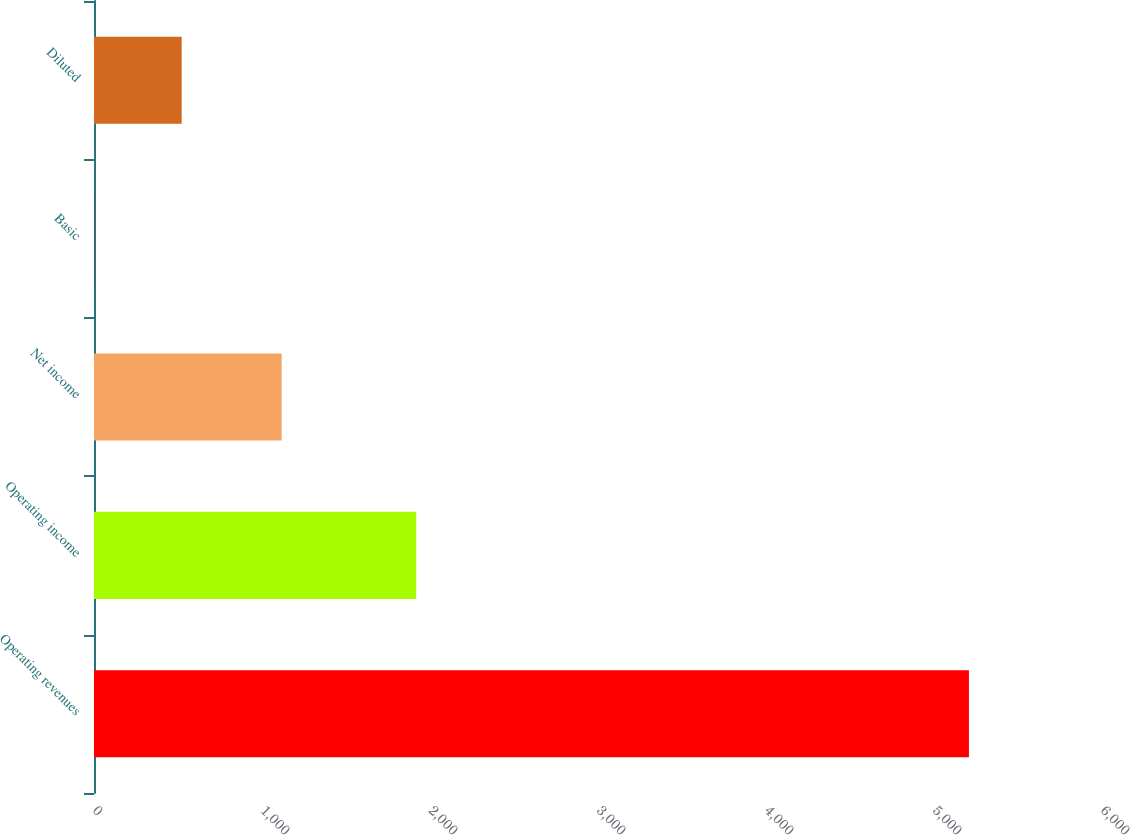<chart> <loc_0><loc_0><loc_500><loc_500><bar_chart><fcel>Operating revenues<fcel>Operating income<fcel>Net income<fcel>Basic<fcel>Diluted<nl><fcel>5208<fcel>1918<fcel>1117<fcel>1.31<fcel>521.98<nl></chart> 